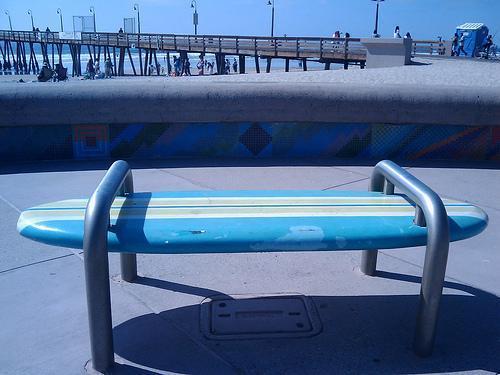How many lamp posts are visible?
Give a very brief answer. 7. 